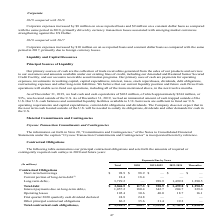According to Sealed Air Corporation's financial document, What does this table represent? summarizes our principal contractual obligations and sets forth the amounts of required or contingently required cash outlays in 2020 and future years:. The document states: "The following table summarizes our principal contractual obligations and sets forth the amounts of required or contingently required cash outlays in 2..." Also, What is the total Total contractual cash obligations for all years? According to the financial document, 5,120.1 (in millions). The relevant text states: "Total contractual cash obligations (3) $ 5,120.1 $ 388.7 $ 1,353.0 $ 1,742.4 $ 1,636.0..." Also, What assumptions were used to calculate interest payments for Term Loan A Based on the financial document, the answer is interest rates based on stated LIBOR rates as of December 31, 2019; and • all non-US Dollar balances are converted using exchange rates as of December 31, 2019.. Also, can you calculate: What is the Total contractual cash obligations for years 2020-2024 inclusive? Based on the calculation: 388.7+1,353.0+1,742.4, the result is 3484.1 (in millions). This is based on the information: "ash obligations (3) $ 5,120.1 $ 388.7 $ 1,353.0 $ 1,742.4 $ 1,636.0 tractual cash obligations (3) $ 5,120.1 $ 388.7 $ 1,353.0 $ 1,742.4 $ 1,636.0 otal contractual cash obligations (3) $ 5,120.1 $ 388...." The key data points involved are: 1,353.0, 1,742.4, 388.7. Also, can you calculate: What is the Total contractual cash obligations for year 2020 expressed as a proportion of Total contractual cash obligations for all years? Based on the calculation: 388.7/5,120.1, the result is 0.08. This is based on the information: "Total contractual cash obligations (3) $ 5,120.1 $ 388.7 $ 1,353.0 $ 1,742.4 $ 1,636.0 otal contractual cash obligations (3) $ 5,120.1 $ 388.7 $ 1,353.0 $ 1,742.4 $ 1,636.0..." The key data points involved are: 388.7, 5,120.1. Also, can you calculate: What is the percentage change of Operating lease from 2021-2022 to 2023-2024? To answer this question, I need to perform calculations using the financial data. The calculation is: (18.7-40.0)/40.0, which equals -53.25 (percentage). This is based on the information: "Operating leases 105.4 30.6 40.0 18.7 16.1 Operating leases 105.4 30.6 40.0 18.7 16.1..." The key data points involved are: 18.7, 40.0. 